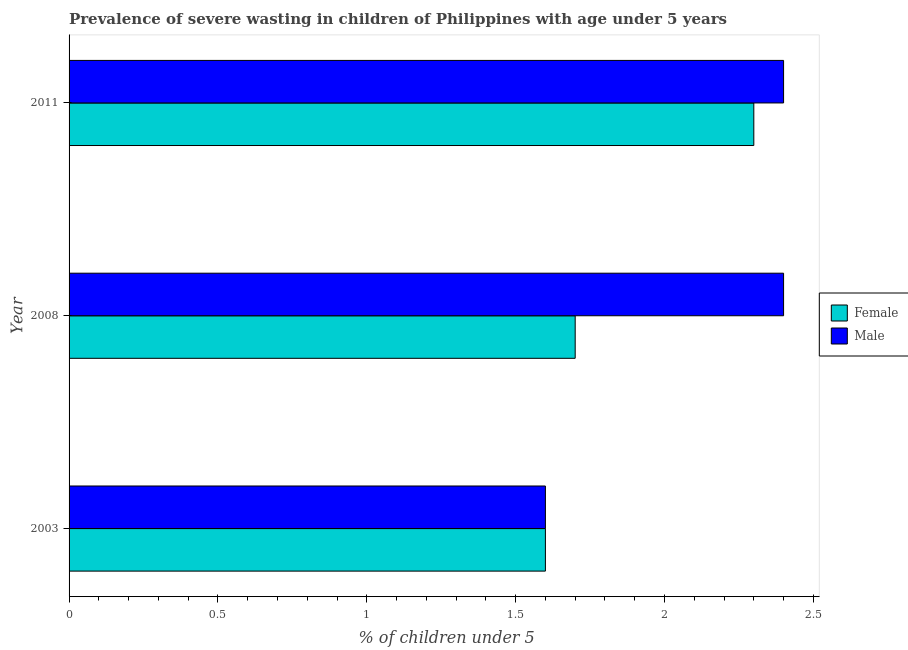How many groups of bars are there?
Your answer should be compact. 3. Are the number of bars per tick equal to the number of legend labels?
Keep it short and to the point. Yes. Are the number of bars on each tick of the Y-axis equal?
Make the answer very short. Yes. How many bars are there on the 1st tick from the bottom?
Your answer should be compact. 2. What is the label of the 1st group of bars from the top?
Keep it short and to the point. 2011. In how many cases, is the number of bars for a given year not equal to the number of legend labels?
Your answer should be very brief. 0. What is the percentage of undernourished male children in 2008?
Your answer should be compact. 2.4. Across all years, what is the maximum percentage of undernourished female children?
Provide a succinct answer. 2.3. Across all years, what is the minimum percentage of undernourished female children?
Your response must be concise. 1.6. In which year was the percentage of undernourished male children maximum?
Give a very brief answer. 2008. In which year was the percentage of undernourished female children minimum?
Your answer should be very brief. 2003. What is the total percentage of undernourished female children in the graph?
Keep it short and to the point. 5.6. What is the difference between the percentage of undernourished male children in 2008 and the percentage of undernourished female children in 2011?
Your answer should be very brief. 0.1. What is the average percentage of undernourished male children per year?
Your answer should be compact. 2.13. In the year 2008, what is the difference between the percentage of undernourished male children and percentage of undernourished female children?
Provide a succinct answer. 0.7. What is the ratio of the percentage of undernourished male children in 2008 to that in 2011?
Make the answer very short. 1. Is the percentage of undernourished female children in 2008 less than that in 2011?
Your answer should be very brief. Yes. Is the difference between the percentage of undernourished female children in 2008 and 2011 greater than the difference between the percentage of undernourished male children in 2008 and 2011?
Your answer should be very brief. No. What is the difference between the highest and the second highest percentage of undernourished male children?
Your answer should be compact. 0. In how many years, is the percentage of undernourished male children greater than the average percentage of undernourished male children taken over all years?
Your answer should be compact. 2. What does the 1st bar from the top in 2003 represents?
Keep it short and to the point. Male. How many bars are there?
Ensure brevity in your answer.  6. Are all the bars in the graph horizontal?
Ensure brevity in your answer.  Yes. How many legend labels are there?
Provide a succinct answer. 2. What is the title of the graph?
Make the answer very short. Prevalence of severe wasting in children of Philippines with age under 5 years. Does "Male labor force" appear as one of the legend labels in the graph?
Keep it short and to the point. No. What is the label or title of the X-axis?
Your answer should be compact.  % of children under 5. What is the label or title of the Y-axis?
Give a very brief answer. Year. What is the  % of children under 5 of Female in 2003?
Provide a short and direct response. 1.6. What is the  % of children under 5 in Male in 2003?
Make the answer very short. 1.6. What is the  % of children under 5 of Female in 2008?
Provide a short and direct response. 1.7. What is the  % of children under 5 of Male in 2008?
Ensure brevity in your answer.  2.4. What is the  % of children under 5 in Female in 2011?
Your answer should be very brief. 2.3. What is the  % of children under 5 in Male in 2011?
Make the answer very short. 2.4. Across all years, what is the maximum  % of children under 5 in Female?
Ensure brevity in your answer.  2.3. Across all years, what is the maximum  % of children under 5 of Male?
Keep it short and to the point. 2.4. Across all years, what is the minimum  % of children under 5 of Female?
Keep it short and to the point. 1.6. Across all years, what is the minimum  % of children under 5 in Male?
Provide a short and direct response. 1.6. What is the total  % of children under 5 in Female in the graph?
Provide a short and direct response. 5.6. What is the difference between the  % of children under 5 in Female in 2003 and that in 2008?
Ensure brevity in your answer.  -0.1. What is the difference between the  % of children under 5 in Male in 2003 and that in 2008?
Offer a terse response. -0.8. What is the difference between the  % of children under 5 of Male in 2003 and that in 2011?
Keep it short and to the point. -0.8. What is the difference between the  % of children under 5 of Female in 2008 and that in 2011?
Ensure brevity in your answer.  -0.6. What is the difference between the  % of children under 5 in Female in 2003 and the  % of children under 5 in Male in 2011?
Ensure brevity in your answer.  -0.8. What is the average  % of children under 5 in Female per year?
Offer a very short reply. 1.87. What is the average  % of children under 5 of Male per year?
Offer a terse response. 2.13. In the year 2011, what is the difference between the  % of children under 5 in Female and  % of children under 5 in Male?
Offer a very short reply. -0.1. What is the ratio of the  % of children under 5 of Female in 2003 to that in 2008?
Keep it short and to the point. 0.94. What is the ratio of the  % of children under 5 in Female in 2003 to that in 2011?
Provide a short and direct response. 0.7. What is the ratio of the  % of children under 5 in Male in 2003 to that in 2011?
Ensure brevity in your answer.  0.67. What is the ratio of the  % of children under 5 of Female in 2008 to that in 2011?
Offer a very short reply. 0.74. What is the difference between the highest and the second highest  % of children under 5 of Female?
Give a very brief answer. 0.6. What is the difference between the highest and the second highest  % of children under 5 of Male?
Your answer should be compact. 0. What is the difference between the highest and the lowest  % of children under 5 of Male?
Keep it short and to the point. 0.8. 